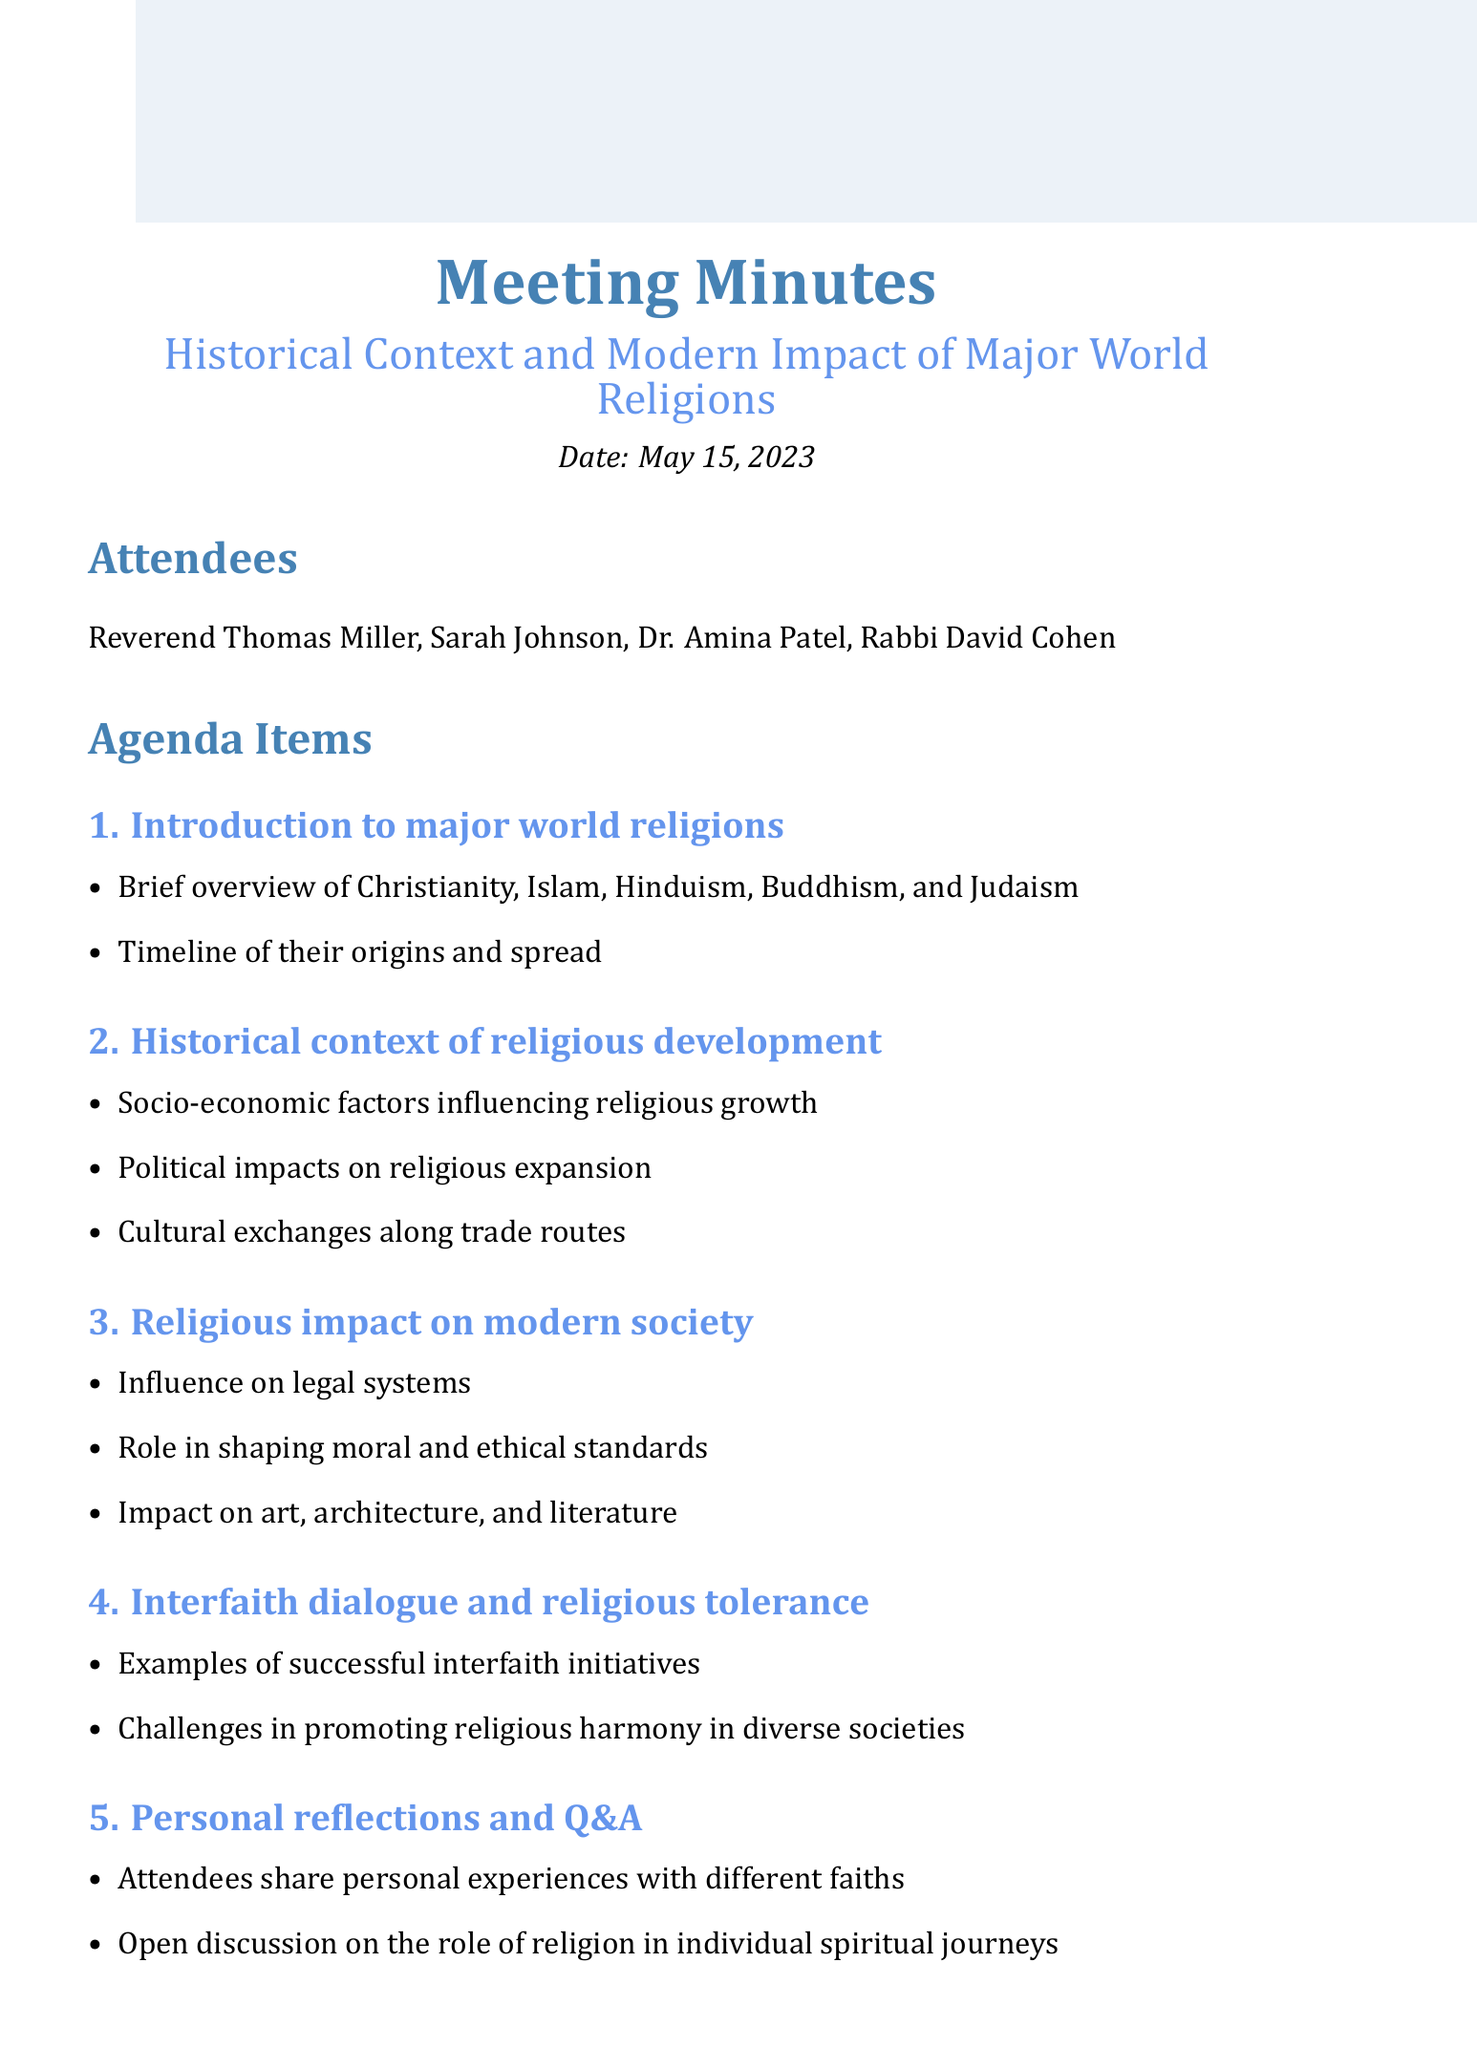What is the meeting title? The meeting title is stated at the beginning of the document.
Answer: Historical Context and Modern Impact of Major World Religions Who are the attendees? The attendees are listed under the "Attendees" section of the document.
Answer: Reverend Thomas Miller, Sarah Johnson, Dr. Amina Patel, Rabbi David Cohen When is the next meeting scheduled? The date for the next meeting is mentioned at the end of the document.
Answer: June 12, 2023 What was discussed in the second agenda item? The second agenda item includes specific points that outline the discussion topic.
Answer: Historical context of religious development How many action items are listed? The number of action items can be counted from the "Action Items" section.
Answer: Three What influences are mentioned regarding legal systems? This point is taken from the discussion about modern society's structure in the document.
Answer: Sharia law, Canon law What successful example is given for interfaith initiatives? The example is directly pointed out within the interfaith dialogue section.
Answer: Parliament of the World's Religions What role do religions play according to the document? The role is indicated during the discussion on religious impacts on modern society.
Answer: Shaping moral and ethical standards What was Reverend Miller's action item? The action item for Reverend Miller is explicitly stated in the "Action Items" section.
Answer: Recommend books on comparative religion 